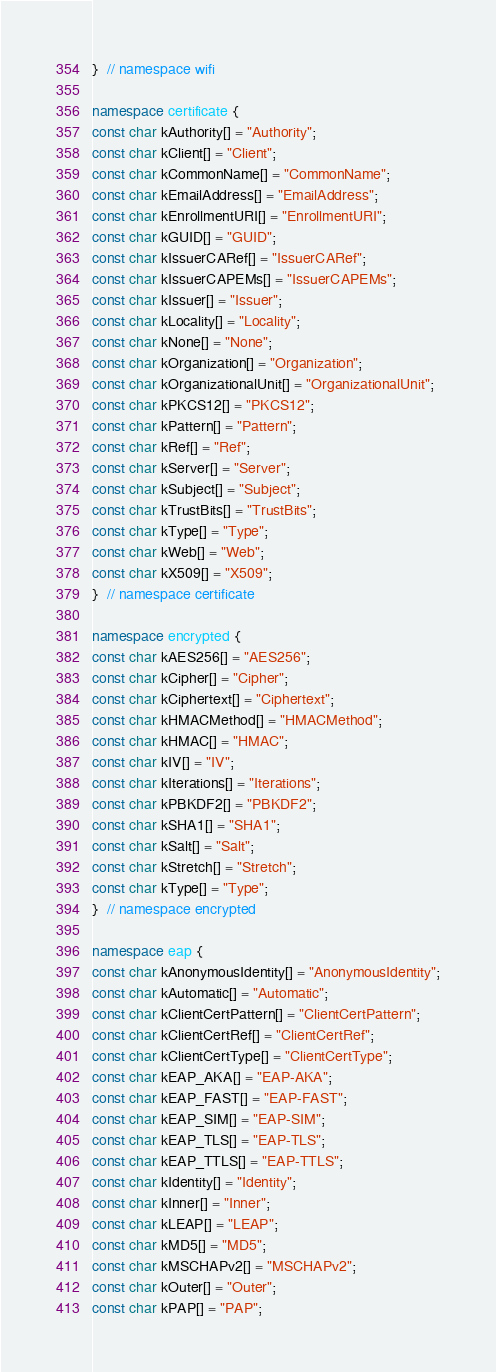Convert code to text. <code><loc_0><loc_0><loc_500><loc_500><_C++_>}  // namespace wifi

namespace certificate {
const char kAuthority[] = "Authority";
const char kClient[] = "Client";
const char kCommonName[] = "CommonName";
const char kEmailAddress[] = "EmailAddress";
const char kEnrollmentURI[] = "EnrollmentURI";
const char kGUID[] = "GUID";
const char kIssuerCARef[] = "IssuerCARef";
const char kIssuerCAPEMs[] = "IssuerCAPEMs";
const char kIssuer[] = "Issuer";
const char kLocality[] = "Locality";
const char kNone[] = "None";
const char kOrganization[] = "Organization";
const char kOrganizationalUnit[] = "OrganizationalUnit";
const char kPKCS12[] = "PKCS12";
const char kPattern[] = "Pattern";
const char kRef[] = "Ref";
const char kServer[] = "Server";
const char kSubject[] = "Subject";
const char kTrustBits[] = "TrustBits";
const char kType[] = "Type";
const char kWeb[] = "Web";
const char kX509[] = "X509";
}  // namespace certificate

namespace encrypted {
const char kAES256[] = "AES256";
const char kCipher[] = "Cipher";
const char kCiphertext[] = "Ciphertext";
const char kHMACMethod[] = "HMACMethod";
const char kHMAC[] = "HMAC";
const char kIV[] = "IV";
const char kIterations[] = "Iterations";
const char kPBKDF2[] = "PBKDF2";
const char kSHA1[] = "SHA1";
const char kSalt[] = "Salt";
const char kStretch[] = "Stretch";
const char kType[] = "Type";
}  // namespace encrypted

namespace eap {
const char kAnonymousIdentity[] = "AnonymousIdentity";
const char kAutomatic[] = "Automatic";
const char kClientCertPattern[] = "ClientCertPattern";
const char kClientCertRef[] = "ClientCertRef";
const char kClientCertType[] = "ClientCertType";
const char kEAP_AKA[] = "EAP-AKA";
const char kEAP_FAST[] = "EAP-FAST";
const char kEAP_SIM[] = "EAP-SIM";
const char kEAP_TLS[] = "EAP-TLS";
const char kEAP_TTLS[] = "EAP-TTLS";
const char kIdentity[] = "Identity";
const char kInner[] = "Inner";
const char kLEAP[] = "LEAP";
const char kMD5[] = "MD5";
const char kMSCHAPv2[] = "MSCHAPv2";
const char kOuter[] = "Outer";
const char kPAP[] = "PAP";</code> 